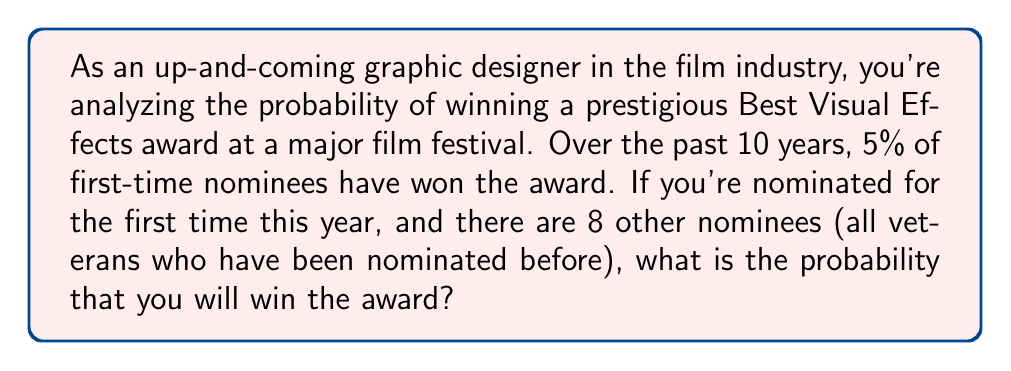Help me with this question. Let's approach this step-by-step:

1) First, we need to understand what the given information tells us:
   - You are a first-time nominee
   - 5% of first-time nominees have won in the past 10 years
   - There are 9 nominees in total (you and 8 others)

2) The probability of you winning as a first-time nominee is 5% or 0.05

3) However, this probability is not the final answer because it doesn't account for the competition. We need to consider the probability of winning given that you are nominated against 8 other people.

4) In probability theory, when only one outcome can occur out of multiple possibilities, and the probabilities of these possibilities sum to 1, we can use the following formula:

   $$P(\text{your win}) = \frac{P(\text{first-time nominee win})}{P(\text{first-time nominee win}) + P(\text{others win})}$$

5) We know $P(\text{first-time nominee win}) = 0.05$

6) $P(\text{others win}) = 1 - 0.05 = 0.95$ (because the probabilities must sum to 1)

7) Now, let's substitute these values into our formula:

   $$P(\text{your win}) = \frac{0.05}{0.05 + 0.95} = \frac{0.05}{1} = 0.05$$

8) Therefore, the probability of you winning the award is 0.05 or 5%
Answer: 0.05 